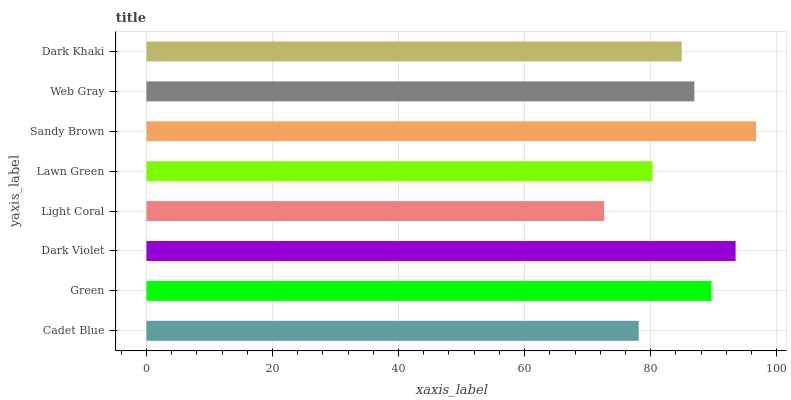Is Light Coral the minimum?
Answer yes or no. Yes. Is Sandy Brown the maximum?
Answer yes or no. Yes. Is Green the minimum?
Answer yes or no. No. Is Green the maximum?
Answer yes or no. No. Is Green greater than Cadet Blue?
Answer yes or no. Yes. Is Cadet Blue less than Green?
Answer yes or no. Yes. Is Cadet Blue greater than Green?
Answer yes or no. No. Is Green less than Cadet Blue?
Answer yes or no. No. Is Web Gray the high median?
Answer yes or no. Yes. Is Dark Khaki the low median?
Answer yes or no. Yes. Is Cadet Blue the high median?
Answer yes or no. No. Is Sandy Brown the low median?
Answer yes or no. No. 